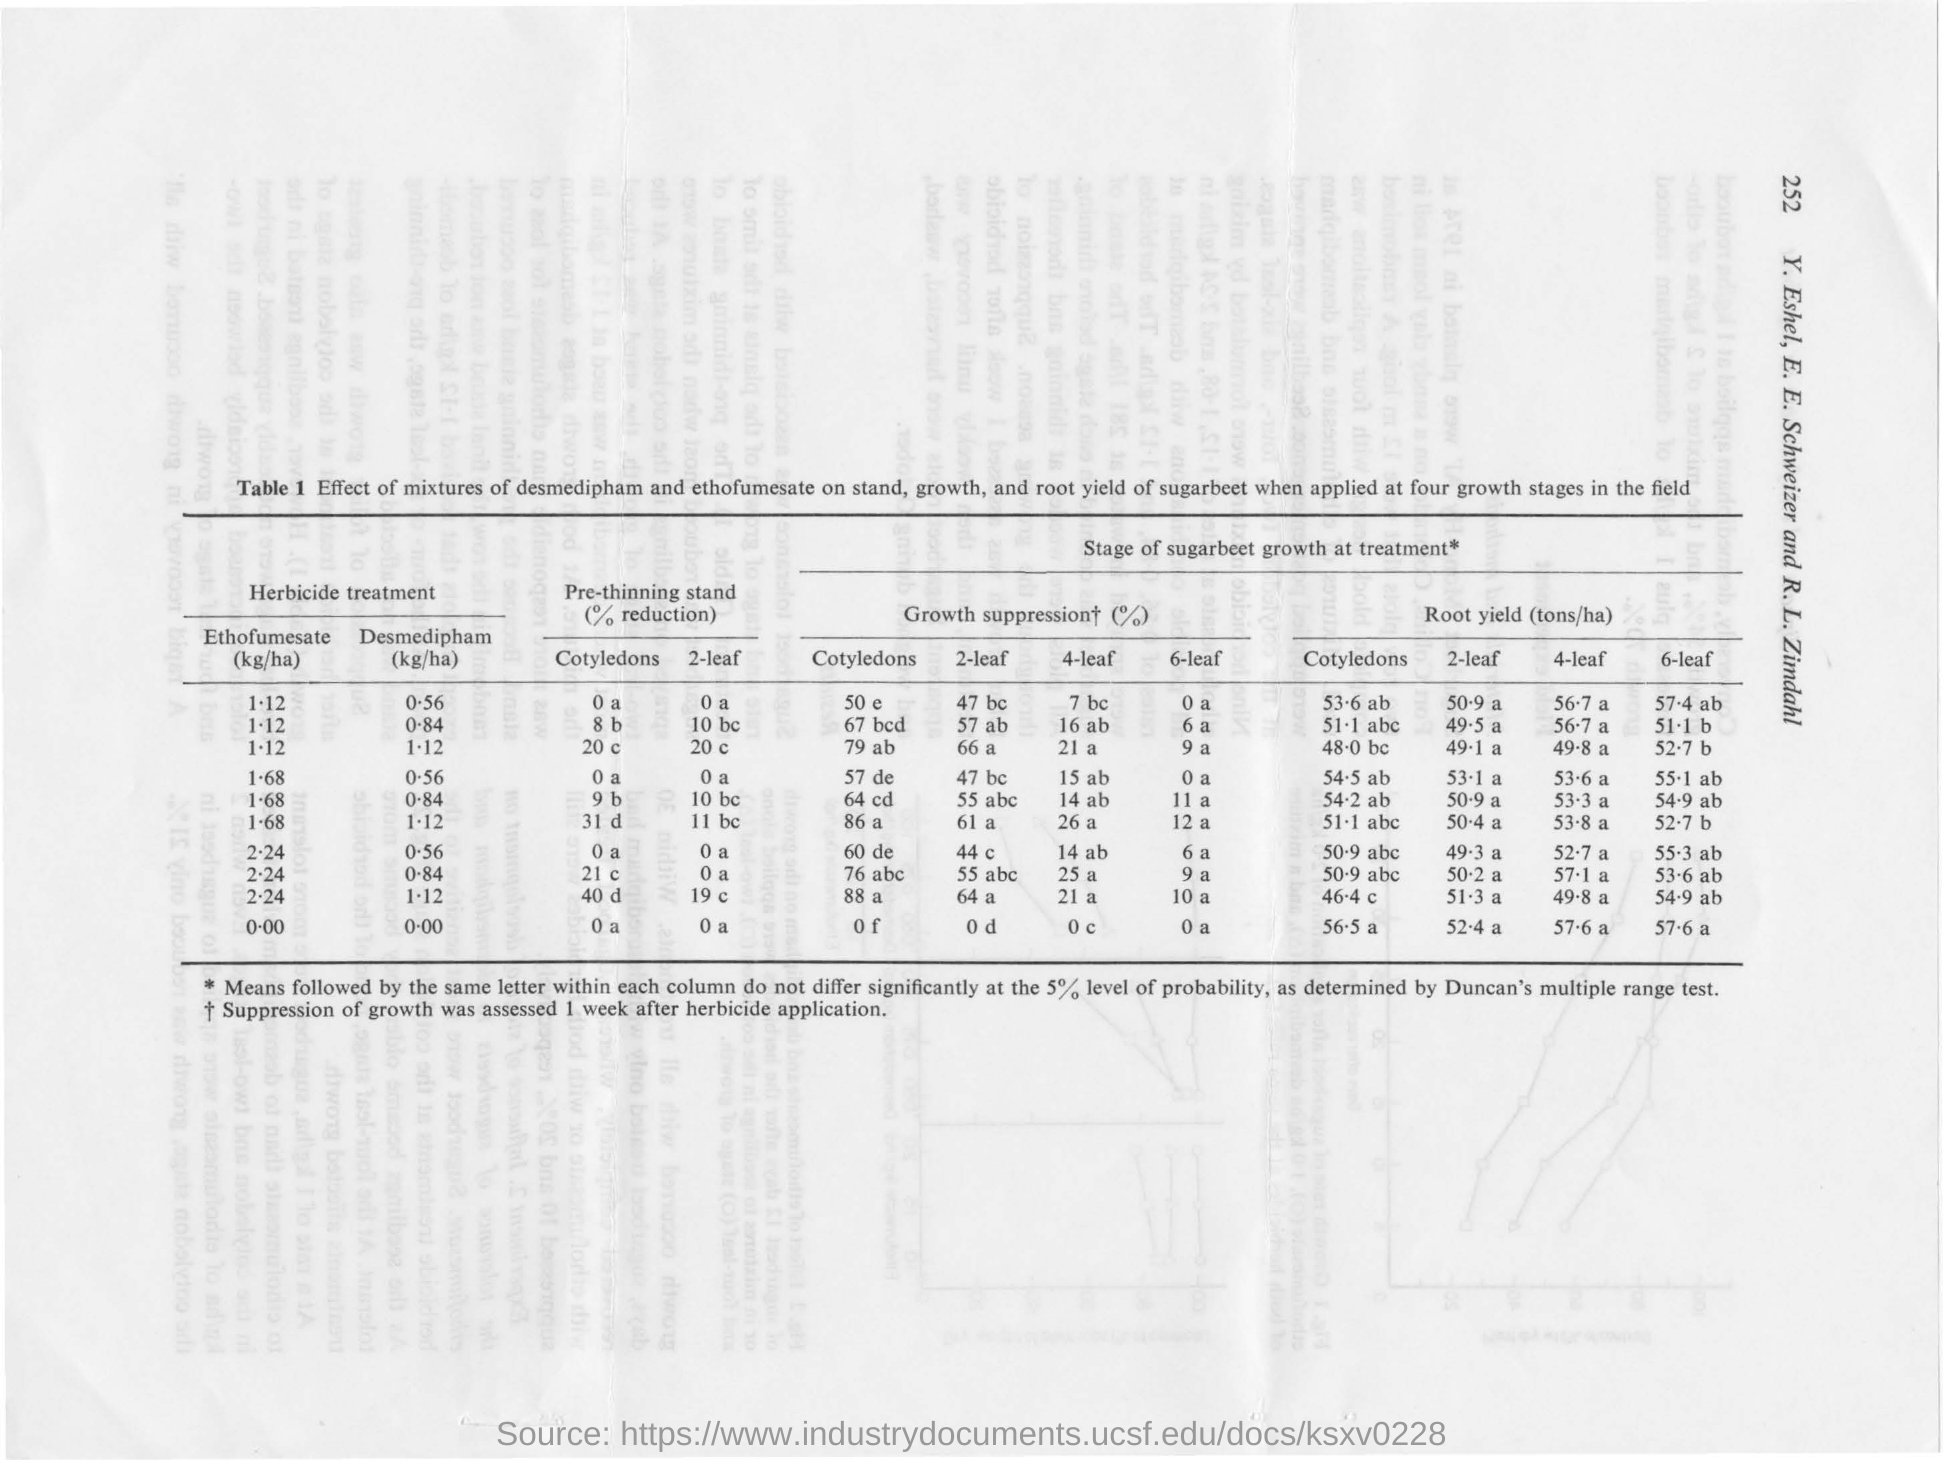What is the page number mentioned?
Keep it short and to the point. 252. Growth stage of which product is mentioned?
Your answer should be compact. SUGARBEET. 